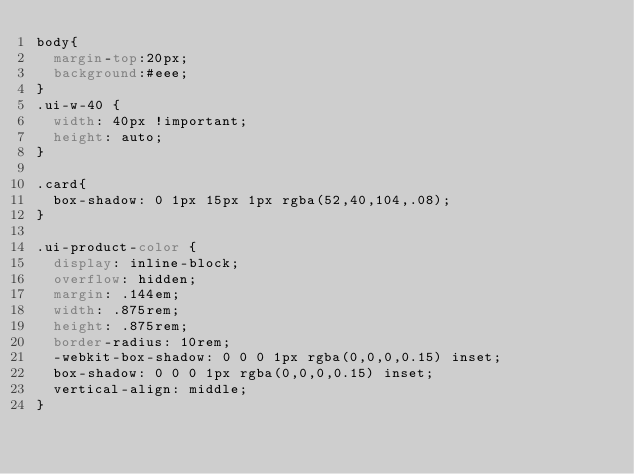<code> <loc_0><loc_0><loc_500><loc_500><_CSS_>body{
  margin-top:20px;
  background:#eee;
}
.ui-w-40 {
  width: 40px !important;
  height: auto;
}

.card{
  box-shadow: 0 1px 15px 1px rgba(52,40,104,.08);    
}

.ui-product-color {
  display: inline-block;
  overflow: hidden;
  margin: .144em;
  width: .875rem;
  height: .875rem;
  border-radius: 10rem;
  -webkit-box-shadow: 0 0 0 1px rgba(0,0,0,0.15) inset;
  box-shadow: 0 0 0 1px rgba(0,0,0,0.15) inset;
  vertical-align: middle;
}</code> 